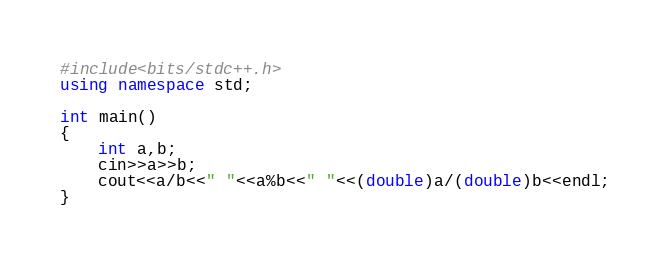Convert code to text. <code><loc_0><loc_0><loc_500><loc_500><_C++_>#include<bits/stdc++.h>
using namespace std;

int main()
{
    int a,b;
    cin>>a>>b;
    cout<<a/b<<" "<<a%b<<" "<<(double)a/(double)b<<endl;
}
</code> 